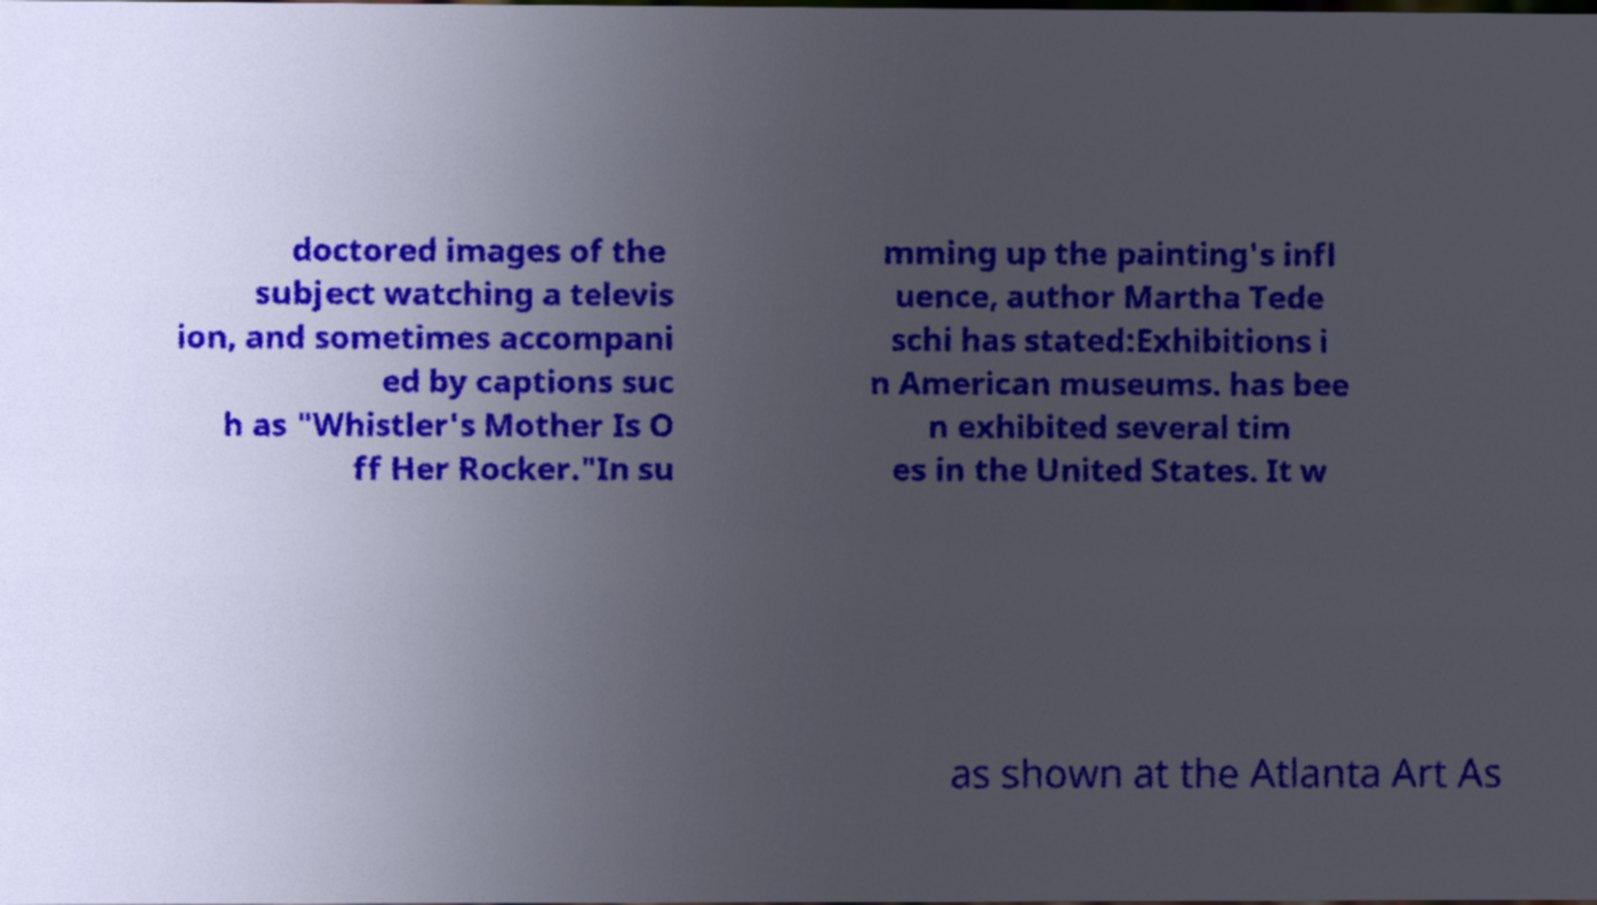Can you read and provide the text displayed in the image?This photo seems to have some interesting text. Can you extract and type it out for me? doctored images of the subject watching a televis ion, and sometimes accompani ed by captions suc h as "Whistler's Mother Is O ff Her Rocker."In su mming up the painting's infl uence, author Martha Tede schi has stated:Exhibitions i n American museums. has bee n exhibited several tim es in the United States. It w as shown at the Atlanta Art As 